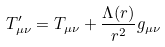<formula> <loc_0><loc_0><loc_500><loc_500>T ^ { \prime } _ { \mu \nu } = T _ { \mu \nu } + \frac { \Lambda ( r ) } { r ^ { 2 } } g _ { \mu \nu }</formula> 